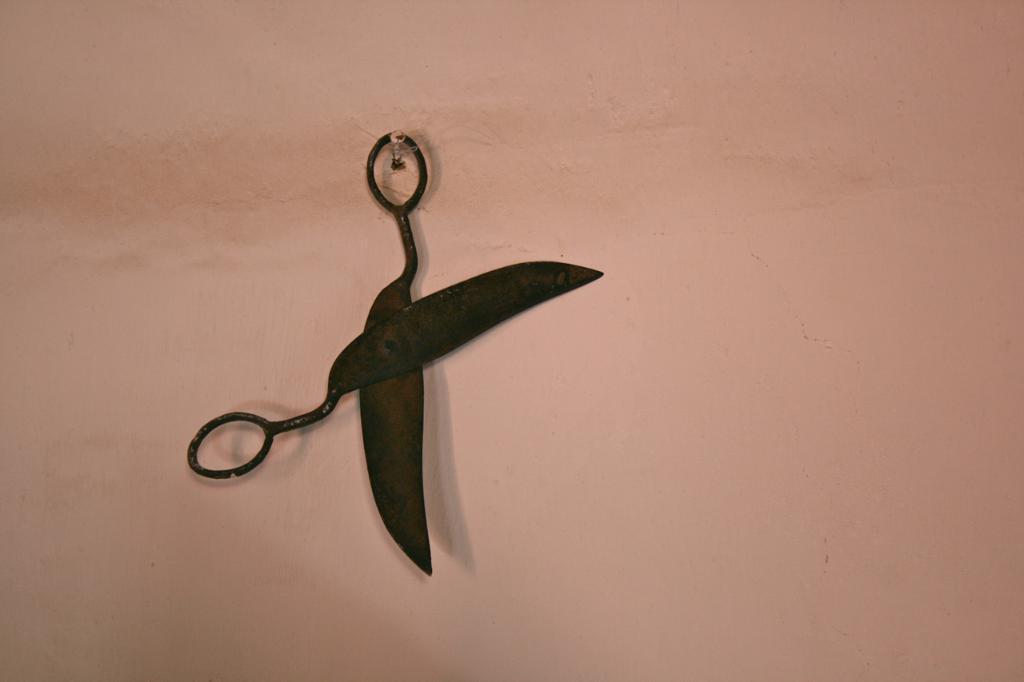Could you give a brief overview of what you see in this image? In this picture i can see a scissor is hanging to a nail which is attached to the wall. 